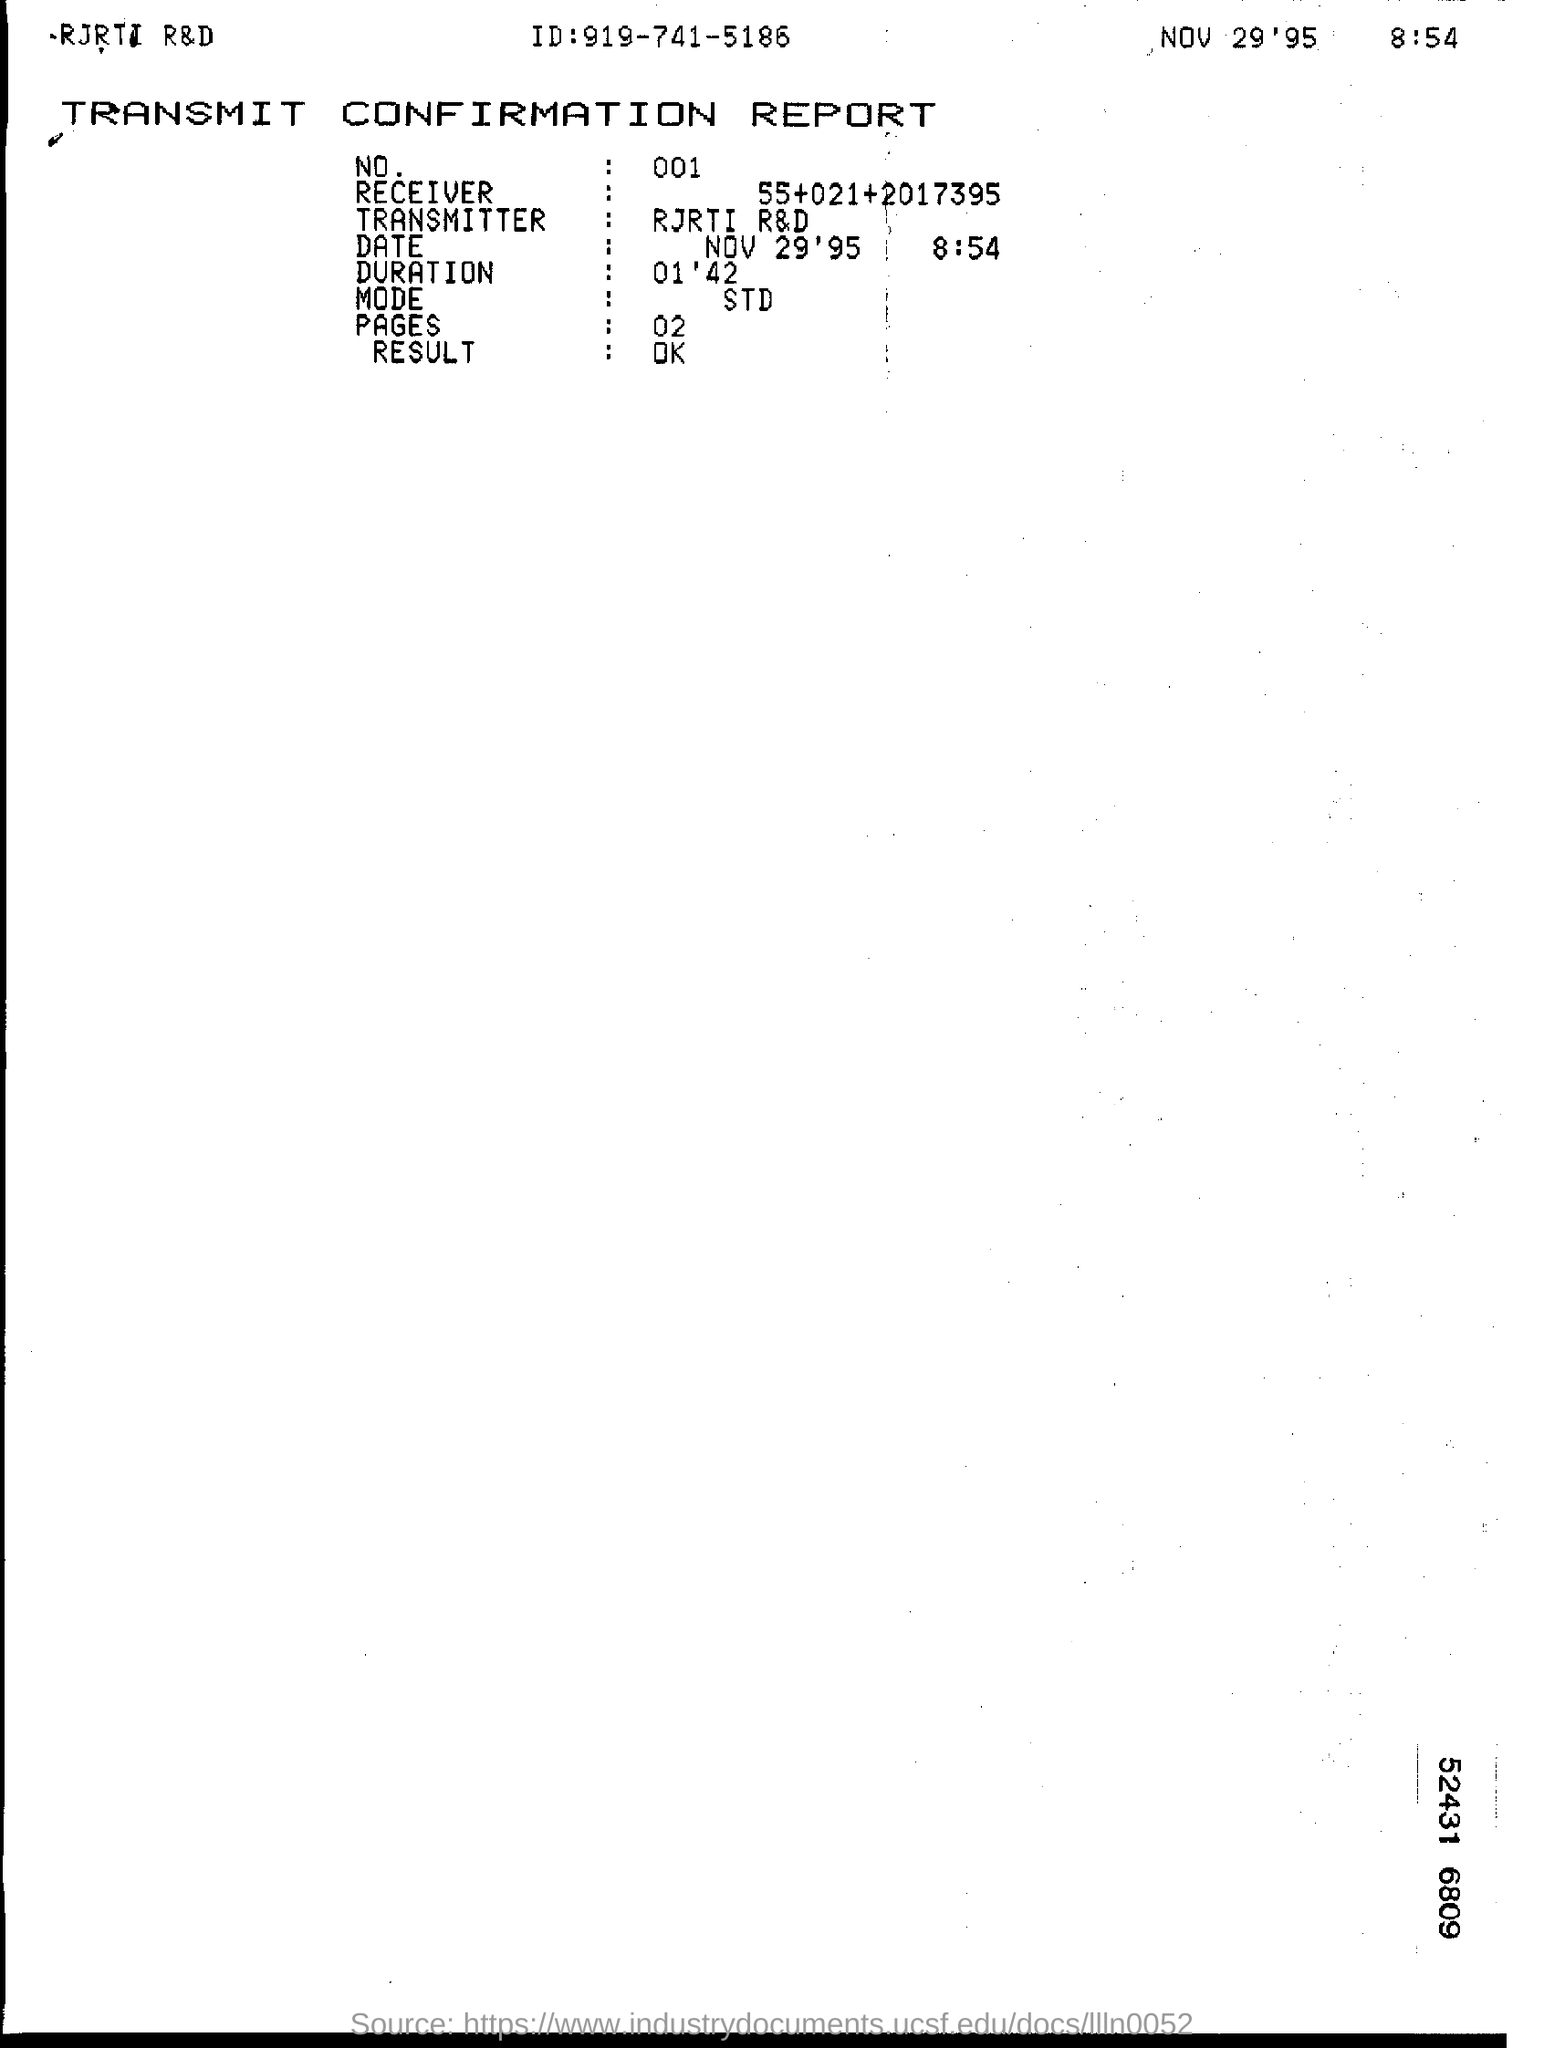Highlight a few significant elements in this photo. The Transmitter is RJRTI's R&D department. The mode is the value in a data set that occurs most frequently and is typically represented by the letter 'M.' Standard deviation is a measure of the spread or dispersion of a data set, calculated as the square root of the variance. The result is OK. What is the number? The duration is approximately 1 minute and 42 seconds. 